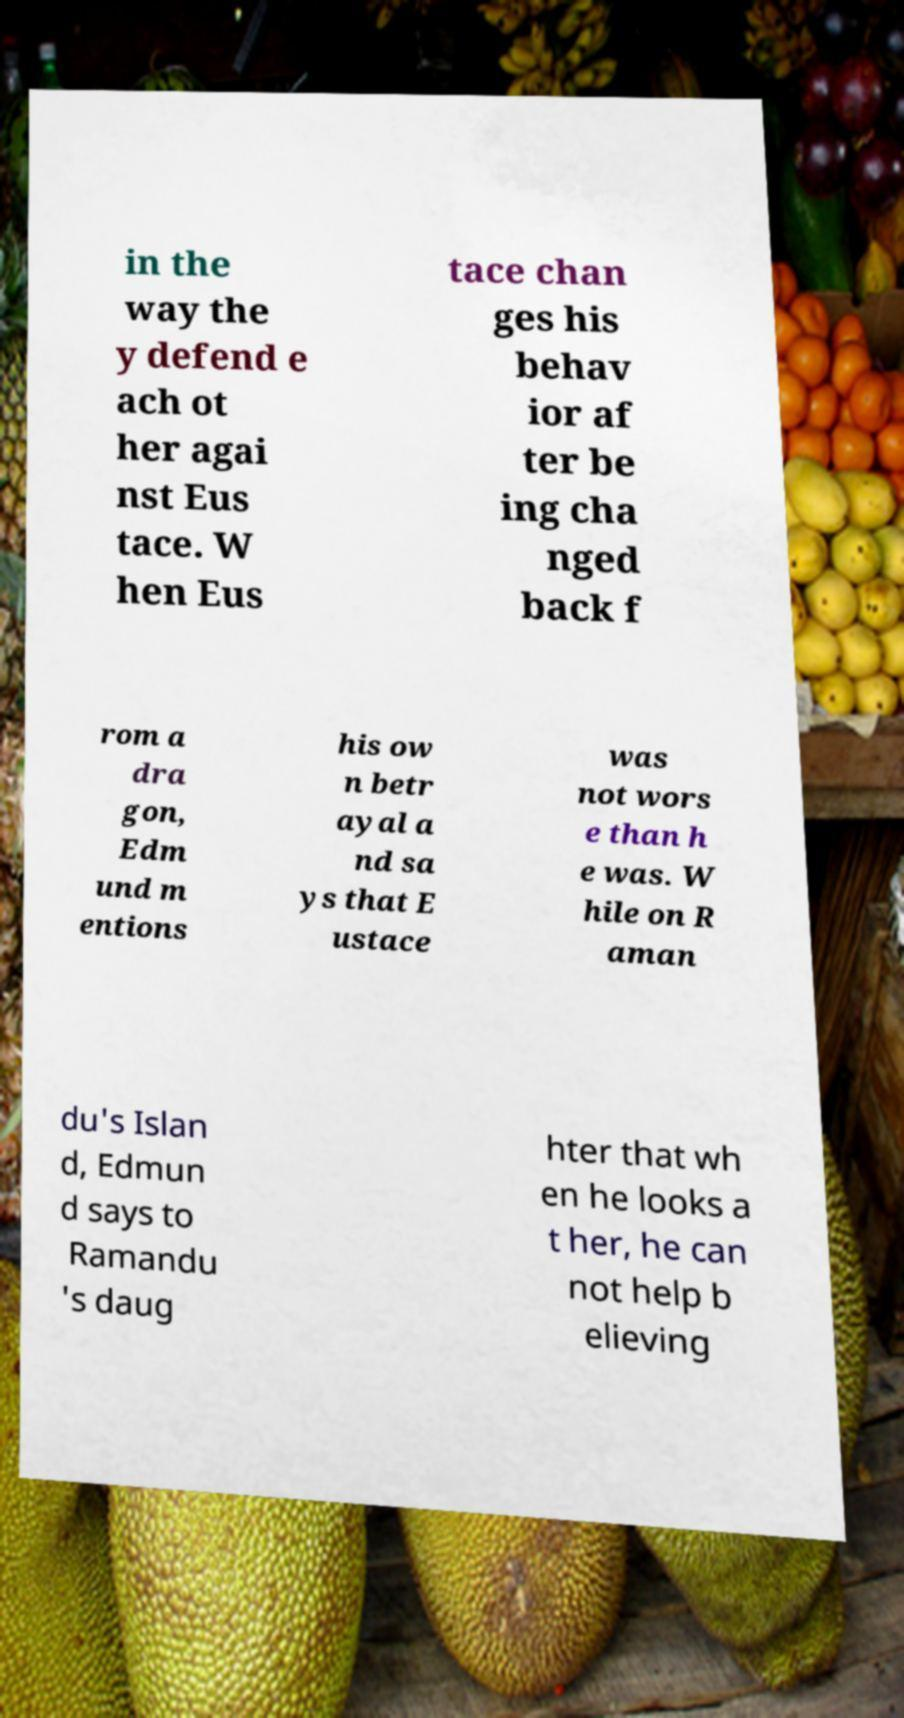For documentation purposes, I need the text within this image transcribed. Could you provide that? in the way the y defend e ach ot her agai nst Eus tace. W hen Eus tace chan ges his behav ior af ter be ing cha nged back f rom a dra gon, Edm und m entions his ow n betr ayal a nd sa ys that E ustace was not wors e than h e was. W hile on R aman du's Islan d, Edmun d says to Ramandu 's daug hter that wh en he looks a t her, he can not help b elieving 